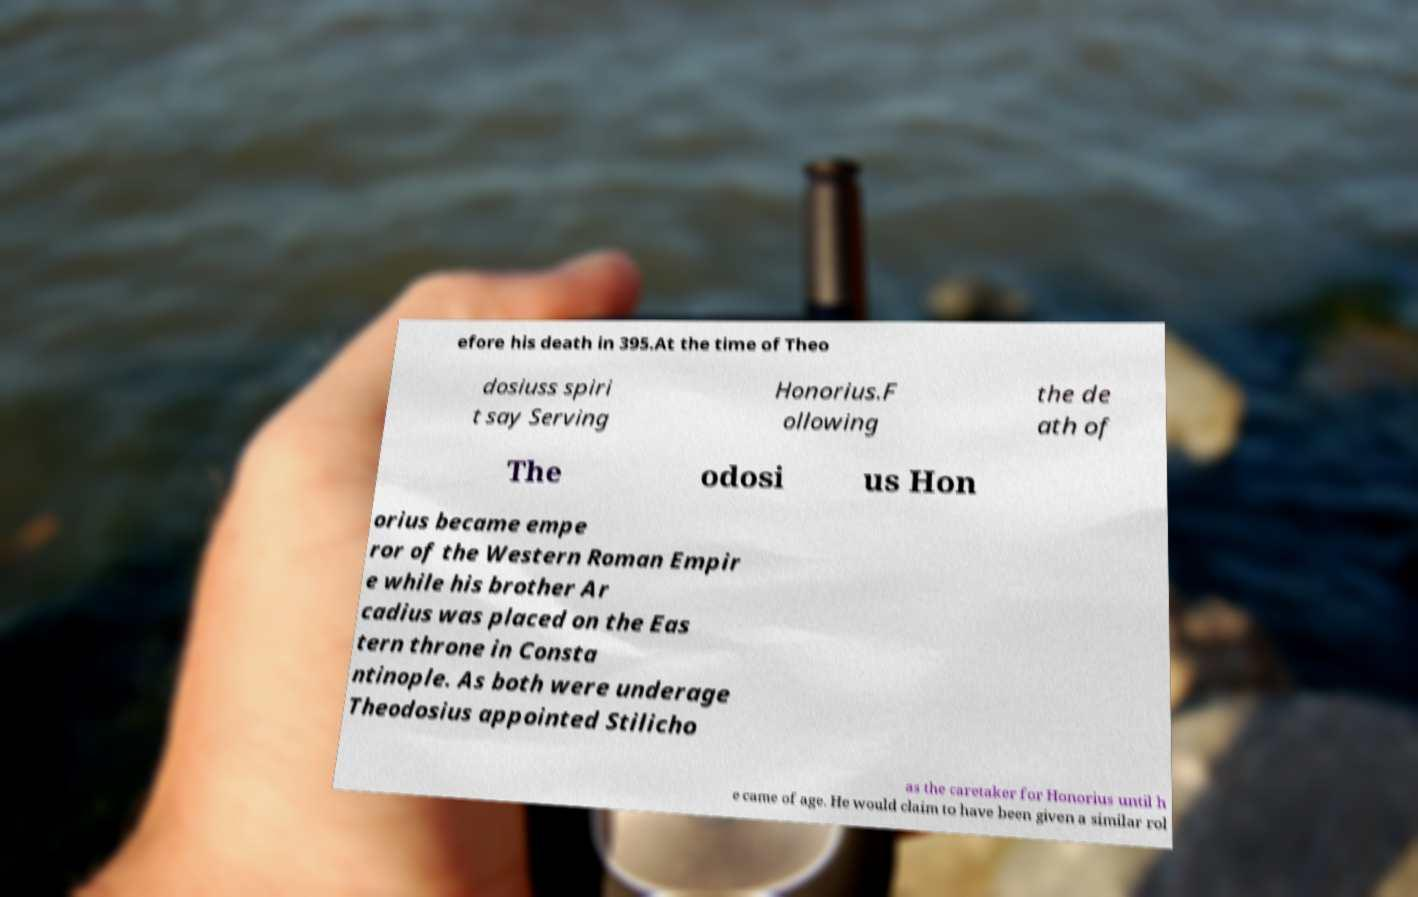Can you accurately transcribe the text from the provided image for me? efore his death in 395.At the time of Theo dosiuss spiri t say Serving Honorius.F ollowing the de ath of The odosi us Hon orius became empe ror of the Western Roman Empir e while his brother Ar cadius was placed on the Eas tern throne in Consta ntinople. As both were underage Theodosius appointed Stilicho as the caretaker for Honorius until h e came of age. He would claim to have been given a similar rol 